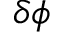Convert formula to latex. <formula><loc_0><loc_0><loc_500><loc_500>\delta \phi</formula> 